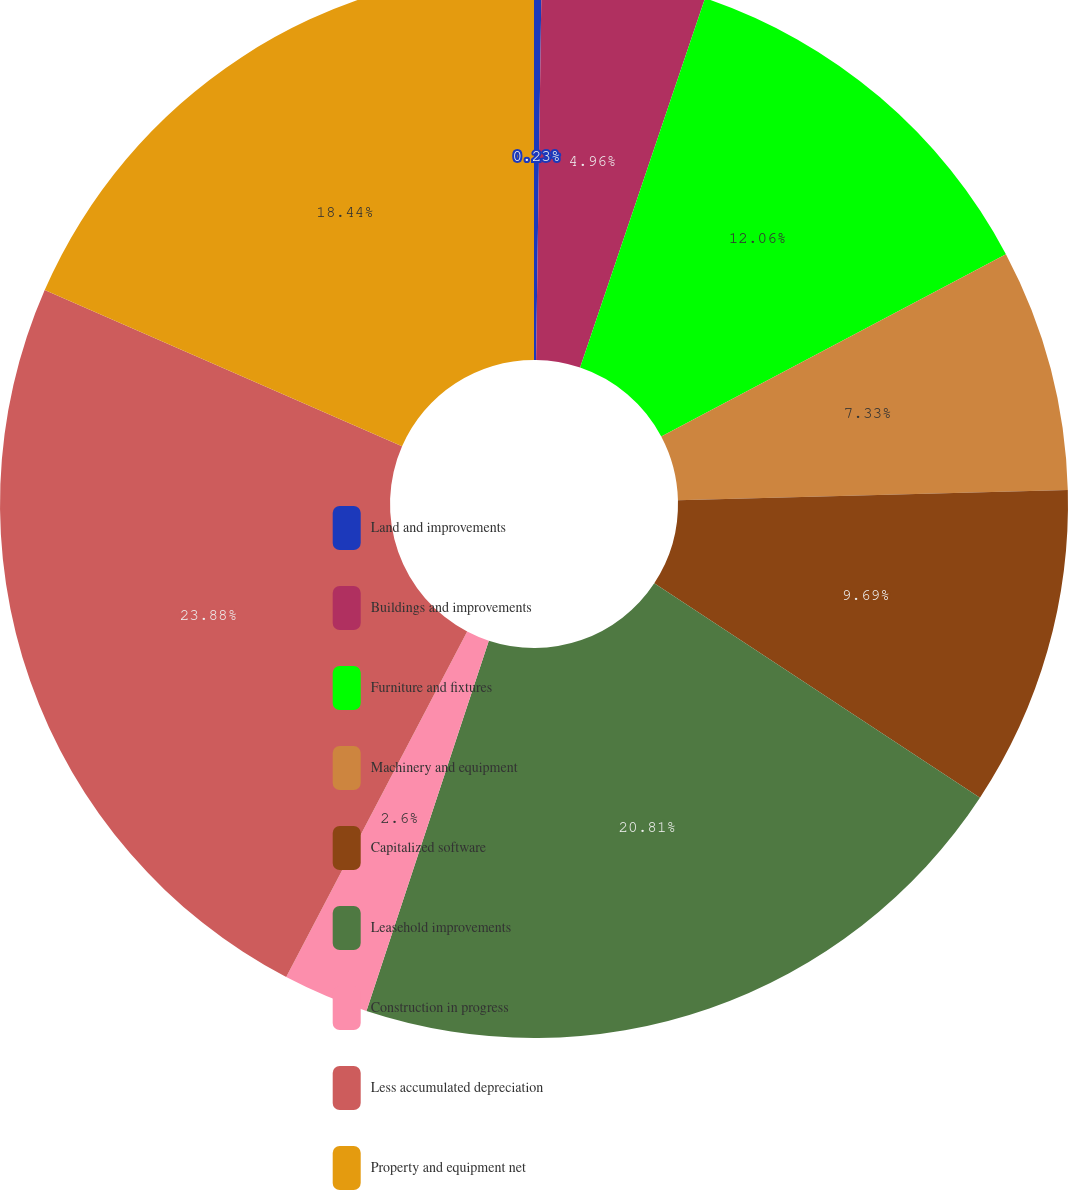<chart> <loc_0><loc_0><loc_500><loc_500><pie_chart><fcel>Land and improvements<fcel>Buildings and improvements<fcel>Furniture and fixtures<fcel>Machinery and equipment<fcel>Capitalized software<fcel>Leasehold improvements<fcel>Construction in progress<fcel>Less accumulated depreciation<fcel>Property and equipment net<nl><fcel>0.23%<fcel>4.96%<fcel>12.06%<fcel>7.33%<fcel>9.69%<fcel>20.81%<fcel>2.6%<fcel>23.88%<fcel>18.44%<nl></chart> 